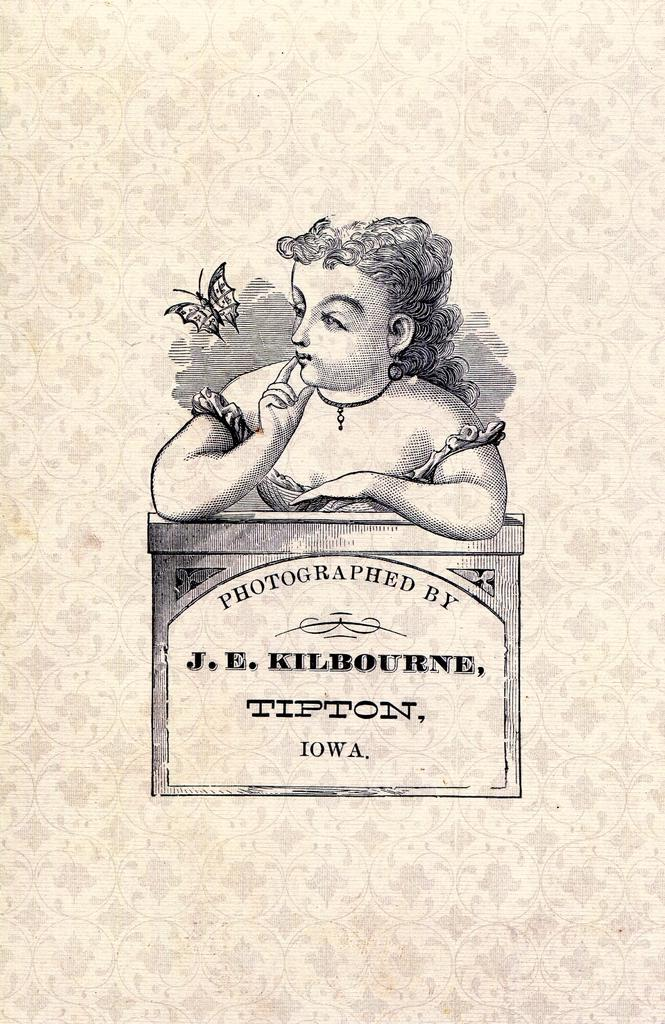What is the main subject in the center of the image? There is a poster in the center of the image. What is depicted on the poster? The poster features a person and a butterfly. What else can be seen on the poster? The poster has an object with some text and a design. Where is the rock placed on the desk in the image? There is no rock or desk present in the image; it only features a poster. 